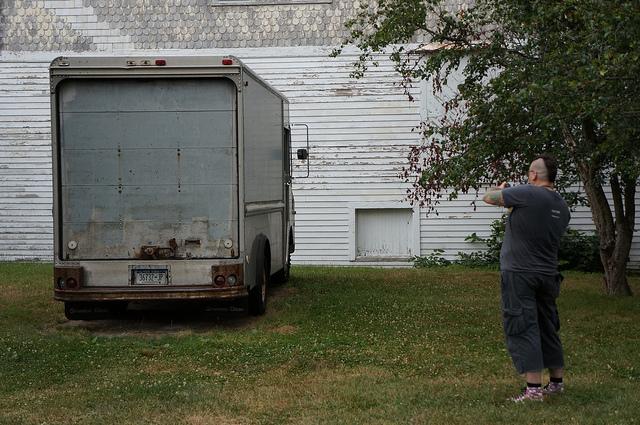What is next to the truck?
Keep it brief. Tree. What has happened to the paint on the building?
Give a very brief answer. Peeling. What kind of haircut does the man have?
Give a very brief answer. Mohawk. This the truck new?
Keep it brief. No. 